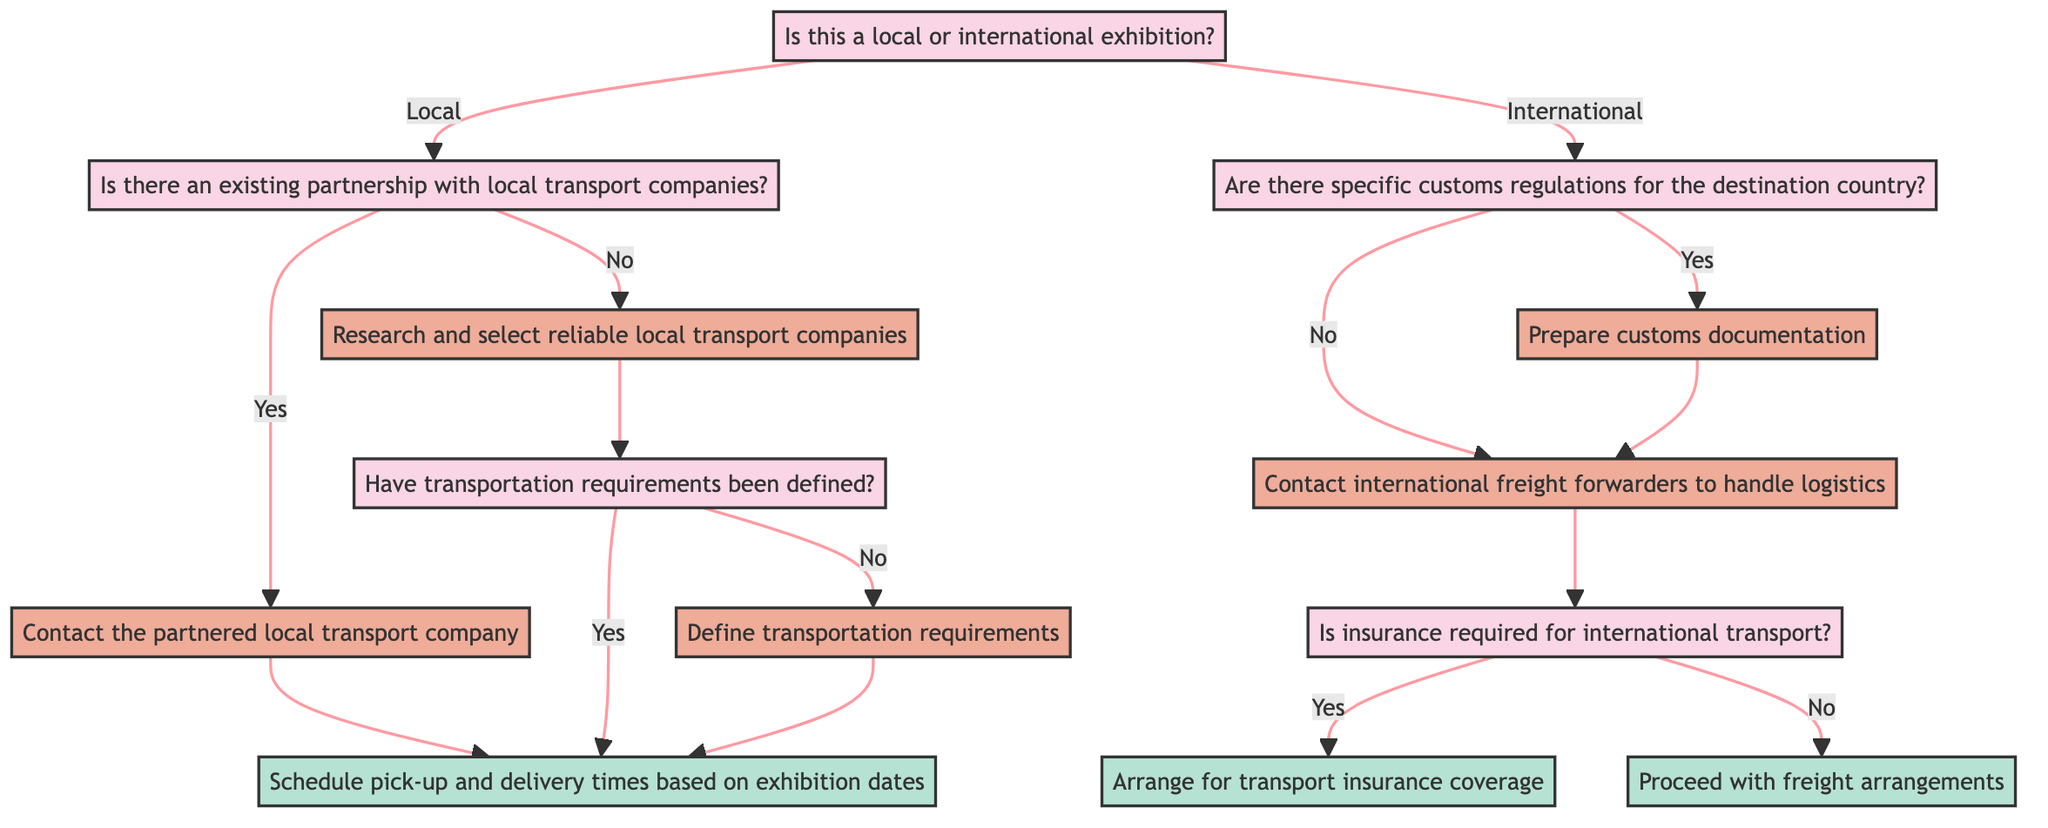What is the starting question of the decision tree? The top node in the decision tree is the starting point and presents the main query to categorize the exhibition type. The specific wording of that initial question is "Is this a local or international exhibition?"
Answer: Is this a local or international exhibition? How many options are there at the start of the decision tree? At the start of the decision tree, there are two options stemming from the main question, which are "local" and "international."
Answer: Two What happens if there is an existing partnership with local transport companies? If there is a partnership, the next step according to the flow is to "Contact the partnered local transport company," leading to the following action step related to scheduling.
Answer: Contact the partnered local transport company What is the next step if transportation requirements have not yet been defined? If transportation requirements have not been defined, the flow indicates that the action would be to "Define transportation requirements," which includes specifics like truck size or special handling needs.
Answer: Define transportation requirements What is the consequence if there are specific customs regulations for the destination country? If there are customs regulations, the procedure involves "Prepare customs documentation," which is necessary before contacting freight forwarders. This step is crucial for compliance with international logistics.
Answer: Prepare customs documentation If insurance is required for international transport, what should be arranged? According to the decision tree, if insurance is needed for international transport, the next step will be to "Arrange for transport insurance coverage" to protect against potential risks during shipment.
Answer: Arrange for transport insurance coverage What action follows after contacting international freight forwarders when no customs regulations exist? If no customs regulations exist, the next action after contacting international freight forwarders will be "Is insurance required for international transport?" This question refers to risk management in the logistics process.
Answer: Is insurance required for international transport? What are the two outcomes after defining transportation requirements? After defining transportation requirements, the outcomes are scheduling "pick-up and delivery times based on exhibition dates," which is one potential action that directly leads to logistics planning.
Answer: Schedule pick-up and delivery times based on exhibition dates 